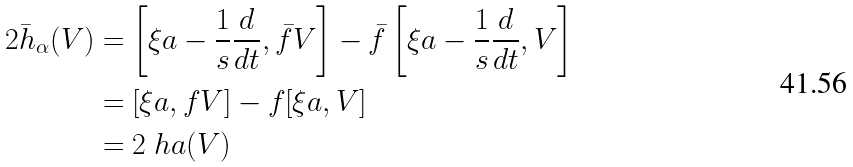Convert formula to latex. <formula><loc_0><loc_0><loc_500><loc_500>2 \bar { h } _ { \alpha } ( V ) & = \left [ \xi a - \frac { 1 } { s } \frac { d } { d t } , \bar { f } V \right ] - \bar { f } \left [ \xi a - \frac { 1 } { s } \frac { d } { d t } , V \right ] \\ & = [ \xi a , { f } V ] - f [ \xi a , V ] \\ & = 2 \ h a ( V ) \\</formula> 